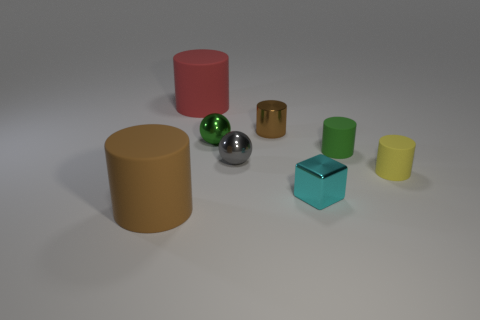Subtract 1 cylinders. How many cylinders are left? 4 Subtract all yellow cylinders. How many cylinders are left? 4 Subtract all green rubber cylinders. How many cylinders are left? 4 Subtract all blue cylinders. Subtract all yellow balls. How many cylinders are left? 5 Add 1 tiny green cylinders. How many objects exist? 9 Subtract all cylinders. How many objects are left? 3 Subtract 1 gray spheres. How many objects are left? 7 Subtract all big matte blocks. Subtract all brown cylinders. How many objects are left? 6 Add 1 small shiny blocks. How many small shiny blocks are left? 2 Add 1 small metallic cubes. How many small metallic cubes exist? 2 